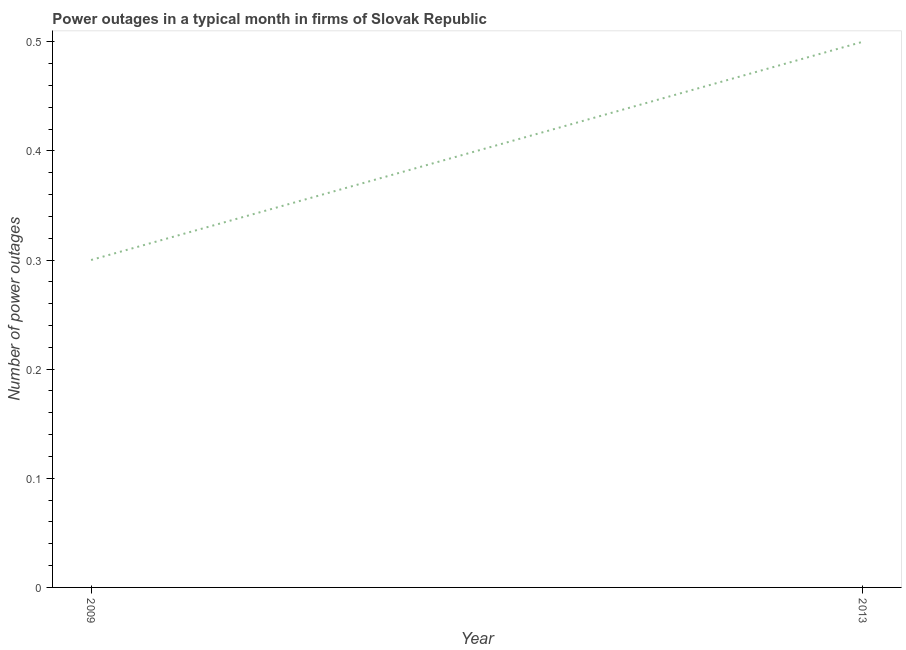What is the number of power outages in 2013?
Your answer should be compact. 0.5. Across all years, what is the maximum number of power outages?
Offer a terse response. 0.5. In which year was the number of power outages maximum?
Keep it short and to the point. 2013. In which year was the number of power outages minimum?
Provide a short and direct response. 2009. What is the sum of the number of power outages?
Your answer should be compact. 0.8. What is the median number of power outages?
Your answer should be very brief. 0.4. In how many years, is the number of power outages greater than 0.28 ?
Give a very brief answer. 2. Do a majority of the years between 2013 and 2009 (inclusive) have number of power outages greater than 0.44 ?
Offer a very short reply. No. What is the ratio of the number of power outages in 2009 to that in 2013?
Your response must be concise. 0.6. How many lines are there?
Keep it short and to the point. 1. How many years are there in the graph?
Give a very brief answer. 2. Does the graph contain grids?
Your answer should be compact. No. What is the title of the graph?
Your answer should be compact. Power outages in a typical month in firms of Slovak Republic. What is the label or title of the Y-axis?
Offer a terse response. Number of power outages. What is the ratio of the Number of power outages in 2009 to that in 2013?
Make the answer very short. 0.6. 